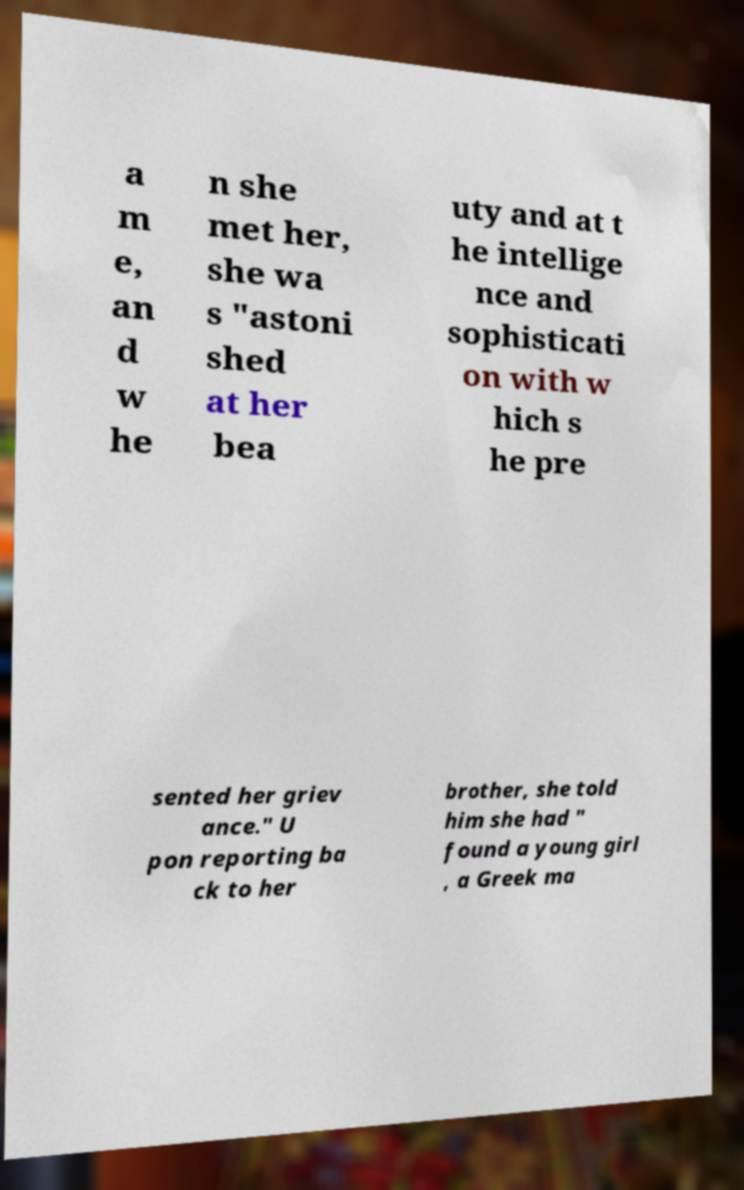For documentation purposes, I need the text within this image transcribed. Could you provide that? a m e, an d w he n she met her, she wa s "astoni shed at her bea uty and at t he intellige nce and sophisticati on with w hich s he pre sented her griev ance." U pon reporting ba ck to her brother, she told him she had " found a young girl , a Greek ma 